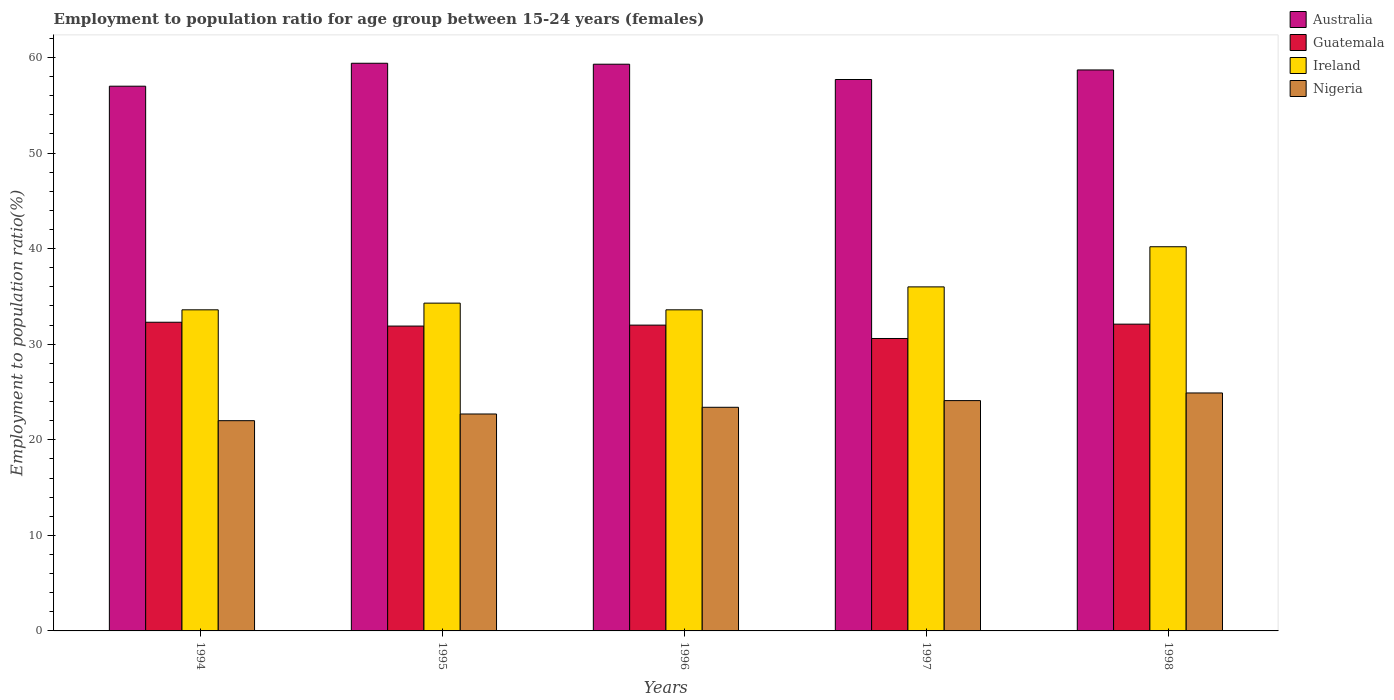How many bars are there on the 5th tick from the left?
Your answer should be compact. 4. How many bars are there on the 4th tick from the right?
Your response must be concise. 4. In how many cases, is the number of bars for a given year not equal to the number of legend labels?
Offer a terse response. 0. Across all years, what is the maximum employment to population ratio in Ireland?
Your answer should be very brief. 40.2. Across all years, what is the minimum employment to population ratio in Guatemala?
Offer a terse response. 30.6. What is the total employment to population ratio in Guatemala in the graph?
Offer a terse response. 158.9. What is the difference between the employment to population ratio in Australia in 1994 and that in 1995?
Ensure brevity in your answer.  -2.4. What is the difference between the employment to population ratio in Ireland in 1998 and the employment to population ratio in Nigeria in 1996?
Your answer should be compact. 16.8. What is the average employment to population ratio in Nigeria per year?
Give a very brief answer. 23.42. In the year 1994, what is the difference between the employment to population ratio in Australia and employment to population ratio in Ireland?
Your answer should be compact. 23.4. In how many years, is the employment to population ratio in Nigeria greater than 2 %?
Keep it short and to the point. 5. What is the ratio of the employment to population ratio in Guatemala in 1994 to that in 1998?
Provide a short and direct response. 1.01. Is the difference between the employment to population ratio in Australia in 1997 and 1998 greater than the difference between the employment to population ratio in Ireland in 1997 and 1998?
Give a very brief answer. Yes. What is the difference between the highest and the second highest employment to population ratio in Guatemala?
Your response must be concise. 0.2. What is the difference between the highest and the lowest employment to population ratio in Australia?
Your answer should be very brief. 2.4. What does the 4th bar from the left in 1994 represents?
Provide a succinct answer. Nigeria. What does the 4th bar from the right in 1996 represents?
Offer a very short reply. Australia. Are all the bars in the graph horizontal?
Keep it short and to the point. No. What is the difference between two consecutive major ticks on the Y-axis?
Your answer should be very brief. 10. Does the graph contain grids?
Provide a short and direct response. No. Where does the legend appear in the graph?
Provide a succinct answer. Top right. How are the legend labels stacked?
Your answer should be compact. Vertical. What is the title of the graph?
Offer a very short reply. Employment to population ratio for age group between 15-24 years (females). Does "Mongolia" appear as one of the legend labels in the graph?
Make the answer very short. No. What is the label or title of the X-axis?
Your answer should be compact. Years. What is the label or title of the Y-axis?
Your answer should be compact. Employment to population ratio(%). What is the Employment to population ratio(%) of Australia in 1994?
Give a very brief answer. 57. What is the Employment to population ratio(%) in Guatemala in 1994?
Offer a terse response. 32.3. What is the Employment to population ratio(%) in Ireland in 1994?
Offer a terse response. 33.6. What is the Employment to population ratio(%) in Australia in 1995?
Provide a short and direct response. 59.4. What is the Employment to population ratio(%) of Guatemala in 1995?
Provide a succinct answer. 31.9. What is the Employment to population ratio(%) of Ireland in 1995?
Provide a succinct answer. 34.3. What is the Employment to population ratio(%) in Nigeria in 1995?
Offer a terse response. 22.7. What is the Employment to population ratio(%) of Australia in 1996?
Make the answer very short. 59.3. What is the Employment to population ratio(%) in Guatemala in 1996?
Ensure brevity in your answer.  32. What is the Employment to population ratio(%) in Ireland in 1996?
Your answer should be very brief. 33.6. What is the Employment to population ratio(%) of Nigeria in 1996?
Ensure brevity in your answer.  23.4. What is the Employment to population ratio(%) of Australia in 1997?
Make the answer very short. 57.7. What is the Employment to population ratio(%) in Guatemala in 1997?
Give a very brief answer. 30.6. What is the Employment to population ratio(%) of Ireland in 1997?
Your response must be concise. 36. What is the Employment to population ratio(%) of Nigeria in 1997?
Keep it short and to the point. 24.1. What is the Employment to population ratio(%) of Australia in 1998?
Give a very brief answer. 58.7. What is the Employment to population ratio(%) in Guatemala in 1998?
Provide a short and direct response. 32.1. What is the Employment to population ratio(%) of Ireland in 1998?
Your answer should be compact. 40.2. What is the Employment to population ratio(%) of Nigeria in 1998?
Your response must be concise. 24.9. Across all years, what is the maximum Employment to population ratio(%) in Australia?
Provide a short and direct response. 59.4. Across all years, what is the maximum Employment to population ratio(%) in Guatemala?
Your answer should be very brief. 32.3. Across all years, what is the maximum Employment to population ratio(%) of Ireland?
Keep it short and to the point. 40.2. Across all years, what is the maximum Employment to population ratio(%) in Nigeria?
Your response must be concise. 24.9. Across all years, what is the minimum Employment to population ratio(%) in Australia?
Keep it short and to the point. 57. Across all years, what is the minimum Employment to population ratio(%) of Guatemala?
Keep it short and to the point. 30.6. Across all years, what is the minimum Employment to population ratio(%) of Ireland?
Provide a short and direct response. 33.6. What is the total Employment to population ratio(%) in Australia in the graph?
Your answer should be compact. 292.1. What is the total Employment to population ratio(%) in Guatemala in the graph?
Provide a succinct answer. 158.9. What is the total Employment to population ratio(%) in Ireland in the graph?
Offer a very short reply. 177.7. What is the total Employment to population ratio(%) of Nigeria in the graph?
Keep it short and to the point. 117.1. What is the difference between the Employment to population ratio(%) in Guatemala in 1994 and that in 1995?
Your answer should be very brief. 0.4. What is the difference between the Employment to population ratio(%) in Australia in 1994 and that in 1996?
Give a very brief answer. -2.3. What is the difference between the Employment to population ratio(%) of Ireland in 1994 and that in 1996?
Provide a succinct answer. 0. What is the difference between the Employment to population ratio(%) in Nigeria in 1994 and that in 1996?
Give a very brief answer. -1.4. What is the difference between the Employment to population ratio(%) in Ireland in 1994 and that in 1997?
Offer a terse response. -2.4. What is the difference between the Employment to population ratio(%) in Australia in 1994 and that in 1998?
Offer a very short reply. -1.7. What is the difference between the Employment to population ratio(%) in Guatemala in 1994 and that in 1998?
Your answer should be very brief. 0.2. What is the difference between the Employment to population ratio(%) in Ireland in 1994 and that in 1998?
Provide a short and direct response. -6.6. What is the difference between the Employment to population ratio(%) in Nigeria in 1994 and that in 1998?
Your response must be concise. -2.9. What is the difference between the Employment to population ratio(%) in Ireland in 1995 and that in 1996?
Provide a succinct answer. 0.7. What is the difference between the Employment to population ratio(%) of Australia in 1995 and that in 1997?
Your answer should be very brief. 1.7. What is the difference between the Employment to population ratio(%) of Guatemala in 1995 and that in 1997?
Your answer should be compact. 1.3. What is the difference between the Employment to population ratio(%) in Nigeria in 1995 and that in 1998?
Offer a terse response. -2.2. What is the difference between the Employment to population ratio(%) in Ireland in 1996 and that in 1997?
Offer a very short reply. -2.4. What is the difference between the Employment to population ratio(%) of Guatemala in 1996 and that in 1998?
Give a very brief answer. -0.1. What is the difference between the Employment to population ratio(%) of Nigeria in 1996 and that in 1998?
Your answer should be very brief. -1.5. What is the difference between the Employment to population ratio(%) in Australia in 1994 and the Employment to population ratio(%) in Guatemala in 1995?
Your answer should be compact. 25.1. What is the difference between the Employment to population ratio(%) of Australia in 1994 and the Employment to population ratio(%) of Ireland in 1995?
Keep it short and to the point. 22.7. What is the difference between the Employment to population ratio(%) of Australia in 1994 and the Employment to population ratio(%) of Nigeria in 1995?
Your response must be concise. 34.3. What is the difference between the Employment to population ratio(%) in Guatemala in 1994 and the Employment to population ratio(%) in Nigeria in 1995?
Your answer should be very brief. 9.6. What is the difference between the Employment to population ratio(%) in Australia in 1994 and the Employment to population ratio(%) in Guatemala in 1996?
Your answer should be very brief. 25. What is the difference between the Employment to population ratio(%) of Australia in 1994 and the Employment to population ratio(%) of Ireland in 1996?
Make the answer very short. 23.4. What is the difference between the Employment to population ratio(%) in Australia in 1994 and the Employment to population ratio(%) in Nigeria in 1996?
Provide a short and direct response. 33.6. What is the difference between the Employment to population ratio(%) in Guatemala in 1994 and the Employment to population ratio(%) in Ireland in 1996?
Keep it short and to the point. -1.3. What is the difference between the Employment to population ratio(%) in Ireland in 1994 and the Employment to population ratio(%) in Nigeria in 1996?
Offer a terse response. 10.2. What is the difference between the Employment to population ratio(%) of Australia in 1994 and the Employment to population ratio(%) of Guatemala in 1997?
Your answer should be very brief. 26.4. What is the difference between the Employment to population ratio(%) of Australia in 1994 and the Employment to population ratio(%) of Nigeria in 1997?
Give a very brief answer. 32.9. What is the difference between the Employment to population ratio(%) in Guatemala in 1994 and the Employment to population ratio(%) in Ireland in 1997?
Give a very brief answer. -3.7. What is the difference between the Employment to population ratio(%) of Ireland in 1994 and the Employment to population ratio(%) of Nigeria in 1997?
Keep it short and to the point. 9.5. What is the difference between the Employment to population ratio(%) of Australia in 1994 and the Employment to population ratio(%) of Guatemala in 1998?
Provide a short and direct response. 24.9. What is the difference between the Employment to population ratio(%) in Australia in 1994 and the Employment to population ratio(%) in Ireland in 1998?
Keep it short and to the point. 16.8. What is the difference between the Employment to population ratio(%) of Australia in 1994 and the Employment to population ratio(%) of Nigeria in 1998?
Ensure brevity in your answer.  32.1. What is the difference between the Employment to population ratio(%) of Guatemala in 1994 and the Employment to population ratio(%) of Ireland in 1998?
Offer a very short reply. -7.9. What is the difference between the Employment to population ratio(%) of Australia in 1995 and the Employment to population ratio(%) of Guatemala in 1996?
Make the answer very short. 27.4. What is the difference between the Employment to population ratio(%) in Australia in 1995 and the Employment to population ratio(%) in Ireland in 1996?
Provide a short and direct response. 25.8. What is the difference between the Employment to population ratio(%) in Guatemala in 1995 and the Employment to population ratio(%) in Ireland in 1996?
Keep it short and to the point. -1.7. What is the difference between the Employment to population ratio(%) of Guatemala in 1995 and the Employment to population ratio(%) of Nigeria in 1996?
Your answer should be compact. 8.5. What is the difference between the Employment to population ratio(%) in Ireland in 1995 and the Employment to population ratio(%) in Nigeria in 1996?
Offer a very short reply. 10.9. What is the difference between the Employment to population ratio(%) in Australia in 1995 and the Employment to population ratio(%) in Guatemala in 1997?
Your answer should be very brief. 28.8. What is the difference between the Employment to population ratio(%) in Australia in 1995 and the Employment to population ratio(%) in Ireland in 1997?
Your answer should be very brief. 23.4. What is the difference between the Employment to population ratio(%) of Australia in 1995 and the Employment to population ratio(%) of Nigeria in 1997?
Provide a succinct answer. 35.3. What is the difference between the Employment to population ratio(%) of Ireland in 1995 and the Employment to population ratio(%) of Nigeria in 1997?
Offer a very short reply. 10.2. What is the difference between the Employment to population ratio(%) of Australia in 1995 and the Employment to population ratio(%) of Guatemala in 1998?
Provide a short and direct response. 27.3. What is the difference between the Employment to population ratio(%) in Australia in 1995 and the Employment to population ratio(%) in Nigeria in 1998?
Keep it short and to the point. 34.5. What is the difference between the Employment to population ratio(%) in Guatemala in 1995 and the Employment to population ratio(%) in Ireland in 1998?
Ensure brevity in your answer.  -8.3. What is the difference between the Employment to population ratio(%) in Australia in 1996 and the Employment to population ratio(%) in Guatemala in 1997?
Ensure brevity in your answer.  28.7. What is the difference between the Employment to population ratio(%) in Australia in 1996 and the Employment to population ratio(%) in Ireland in 1997?
Your answer should be very brief. 23.3. What is the difference between the Employment to population ratio(%) in Australia in 1996 and the Employment to population ratio(%) in Nigeria in 1997?
Your response must be concise. 35.2. What is the difference between the Employment to population ratio(%) in Guatemala in 1996 and the Employment to population ratio(%) in Nigeria in 1997?
Make the answer very short. 7.9. What is the difference between the Employment to population ratio(%) of Ireland in 1996 and the Employment to population ratio(%) of Nigeria in 1997?
Provide a succinct answer. 9.5. What is the difference between the Employment to population ratio(%) in Australia in 1996 and the Employment to population ratio(%) in Guatemala in 1998?
Offer a very short reply. 27.2. What is the difference between the Employment to population ratio(%) in Australia in 1996 and the Employment to population ratio(%) in Nigeria in 1998?
Provide a succinct answer. 34.4. What is the difference between the Employment to population ratio(%) in Guatemala in 1996 and the Employment to population ratio(%) in Ireland in 1998?
Ensure brevity in your answer.  -8.2. What is the difference between the Employment to population ratio(%) in Ireland in 1996 and the Employment to population ratio(%) in Nigeria in 1998?
Your response must be concise. 8.7. What is the difference between the Employment to population ratio(%) in Australia in 1997 and the Employment to population ratio(%) in Guatemala in 1998?
Offer a terse response. 25.6. What is the difference between the Employment to population ratio(%) of Australia in 1997 and the Employment to population ratio(%) of Nigeria in 1998?
Offer a terse response. 32.8. What is the difference between the Employment to population ratio(%) in Guatemala in 1997 and the Employment to population ratio(%) in Ireland in 1998?
Provide a short and direct response. -9.6. What is the difference between the Employment to population ratio(%) in Guatemala in 1997 and the Employment to population ratio(%) in Nigeria in 1998?
Give a very brief answer. 5.7. What is the average Employment to population ratio(%) of Australia per year?
Make the answer very short. 58.42. What is the average Employment to population ratio(%) in Guatemala per year?
Your response must be concise. 31.78. What is the average Employment to population ratio(%) in Ireland per year?
Your answer should be compact. 35.54. What is the average Employment to population ratio(%) of Nigeria per year?
Your response must be concise. 23.42. In the year 1994, what is the difference between the Employment to population ratio(%) of Australia and Employment to population ratio(%) of Guatemala?
Your response must be concise. 24.7. In the year 1994, what is the difference between the Employment to population ratio(%) in Australia and Employment to population ratio(%) in Ireland?
Provide a succinct answer. 23.4. In the year 1994, what is the difference between the Employment to population ratio(%) of Guatemala and Employment to population ratio(%) of Ireland?
Ensure brevity in your answer.  -1.3. In the year 1994, what is the difference between the Employment to population ratio(%) in Guatemala and Employment to population ratio(%) in Nigeria?
Your answer should be compact. 10.3. In the year 1995, what is the difference between the Employment to population ratio(%) in Australia and Employment to population ratio(%) in Ireland?
Keep it short and to the point. 25.1. In the year 1995, what is the difference between the Employment to population ratio(%) of Australia and Employment to population ratio(%) of Nigeria?
Keep it short and to the point. 36.7. In the year 1995, what is the difference between the Employment to population ratio(%) of Guatemala and Employment to population ratio(%) of Nigeria?
Ensure brevity in your answer.  9.2. In the year 1996, what is the difference between the Employment to population ratio(%) of Australia and Employment to population ratio(%) of Guatemala?
Offer a terse response. 27.3. In the year 1996, what is the difference between the Employment to population ratio(%) in Australia and Employment to population ratio(%) in Ireland?
Provide a short and direct response. 25.7. In the year 1996, what is the difference between the Employment to population ratio(%) of Australia and Employment to population ratio(%) of Nigeria?
Offer a terse response. 35.9. In the year 1996, what is the difference between the Employment to population ratio(%) in Guatemala and Employment to population ratio(%) in Nigeria?
Offer a very short reply. 8.6. In the year 1997, what is the difference between the Employment to population ratio(%) of Australia and Employment to population ratio(%) of Guatemala?
Provide a short and direct response. 27.1. In the year 1997, what is the difference between the Employment to population ratio(%) of Australia and Employment to population ratio(%) of Ireland?
Provide a succinct answer. 21.7. In the year 1997, what is the difference between the Employment to population ratio(%) in Australia and Employment to population ratio(%) in Nigeria?
Your response must be concise. 33.6. In the year 1997, what is the difference between the Employment to population ratio(%) in Guatemala and Employment to population ratio(%) in Nigeria?
Ensure brevity in your answer.  6.5. In the year 1998, what is the difference between the Employment to population ratio(%) of Australia and Employment to population ratio(%) of Guatemala?
Provide a short and direct response. 26.6. In the year 1998, what is the difference between the Employment to population ratio(%) in Australia and Employment to population ratio(%) in Nigeria?
Your response must be concise. 33.8. In the year 1998, what is the difference between the Employment to population ratio(%) of Guatemala and Employment to population ratio(%) of Ireland?
Give a very brief answer. -8.1. What is the ratio of the Employment to population ratio(%) in Australia in 1994 to that in 1995?
Offer a terse response. 0.96. What is the ratio of the Employment to population ratio(%) of Guatemala in 1994 to that in 1995?
Make the answer very short. 1.01. What is the ratio of the Employment to population ratio(%) in Ireland in 1994 to that in 1995?
Your answer should be compact. 0.98. What is the ratio of the Employment to population ratio(%) of Nigeria in 1994 to that in 1995?
Provide a succinct answer. 0.97. What is the ratio of the Employment to population ratio(%) of Australia in 1994 to that in 1996?
Offer a very short reply. 0.96. What is the ratio of the Employment to population ratio(%) in Guatemala in 1994 to that in 1996?
Your answer should be compact. 1.01. What is the ratio of the Employment to population ratio(%) of Nigeria in 1994 to that in 1996?
Make the answer very short. 0.94. What is the ratio of the Employment to population ratio(%) of Australia in 1994 to that in 1997?
Your answer should be compact. 0.99. What is the ratio of the Employment to population ratio(%) in Guatemala in 1994 to that in 1997?
Offer a very short reply. 1.06. What is the ratio of the Employment to population ratio(%) in Nigeria in 1994 to that in 1997?
Your response must be concise. 0.91. What is the ratio of the Employment to population ratio(%) of Australia in 1994 to that in 1998?
Keep it short and to the point. 0.97. What is the ratio of the Employment to population ratio(%) in Ireland in 1994 to that in 1998?
Your answer should be very brief. 0.84. What is the ratio of the Employment to population ratio(%) of Nigeria in 1994 to that in 1998?
Provide a short and direct response. 0.88. What is the ratio of the Employment to population ratio(%) in Ireland in 1995 to that in 1996?
Provide a short and direct response. 1.02. What is the ratio of the Employment to population ratio(%) of Nigeria in 1995 to that in 1996?
Provide a short and direct response. 0.97. What is the ratio of the Employment to population ratio(%) in Australia in 1995 to that in 1997?
Your response must be concise. 1.03. What is the ratio of the Employment to population ratio(%) of Guatemala in 1995 to that in 1997?
Ensure brevity in your answer.  1.04. What is the ratio of the Employment to population ratio(%) of Ireland in 1995 to that in 1997?
Give a very brief answer. 0.95. What is the ratio of the Employment to population ratio(%) of Nigeria in 1995 to that in 1997?
Your answer should be compact. 0.94. What is the ratio of the Employment to population ratio(%) of Australia in 1995 to that in 1998?
Ensure brevity in your answer.  1.01. What is the ratio of the Employment to population ratio(%) in Ireland in 1995 to that in 1998?
Keep it short and to the point. 0.85. What is the ratio of the Employment to population ratio(%) of Nigeria in 1995 to that in 1998?
Provide a succinct answer. 0.91. What is the ratio of the Employment to population ratio(%) of Australia in 1996 to that in 1997?
Your response must be concise. 1.03. What is the ratio of the Employment to population ratio(%) of Guatemala in 1996 to that in 1997?
Ensure brevity in your answer.  1.05. What is the ratio of the Employment to population ratio(%) of Nigeria in 1996 to that in 1997?
Provide a short and direct response. 0.97. What is the ratio of the Employment to population ratio(%) of Australia in 1996 to that in 1998?
Offer a terse response. 1.01. What is the ratio of the Employment to population ratio(%) of Ireland in 1996 to that in 1998?
Offer a very short reply. 0.84. What is the ratio of the Employment to population ratio(%) of Nigeria in 1996 to that in 1998?
Provide a short and direct response. 0.94. What is the ratio of the Employment to population ratio(%) of Australia in 1997 to that in 1998?
Your answer should be compact. 0.98. What is the ratio of the Employment to population ratio(%) in Guatemala in 1997 to that in 1998?
Your answer should be compact. 0.95. What is the ratio of the Employment to population ratio(%) in Ireland in 1997 to that in 1998?
Your answer should be very brief. 0.9. What is the ratio of the Employment to population ratio(%) in Nigeria in 1997 to that in 1998?
Your response must be concise. 0.97. What is the difference between the highest and the second highest Employment to population ratio(%) of Australia?
Provide a succinct answer. 0.1. What is the difference between the highest and the second highest Employment to population ratio(%) of Guatemala?
Your response must be concise. 0.2. What is the difference between the highest and the second highest Employment to population ratio(%) of Ireland?
Your answer should be compact. 4.2. What is the difference between the highest and the second highest Employment to population ratio(%) of Nigeria?
Your answer should be compact. 0.8. 